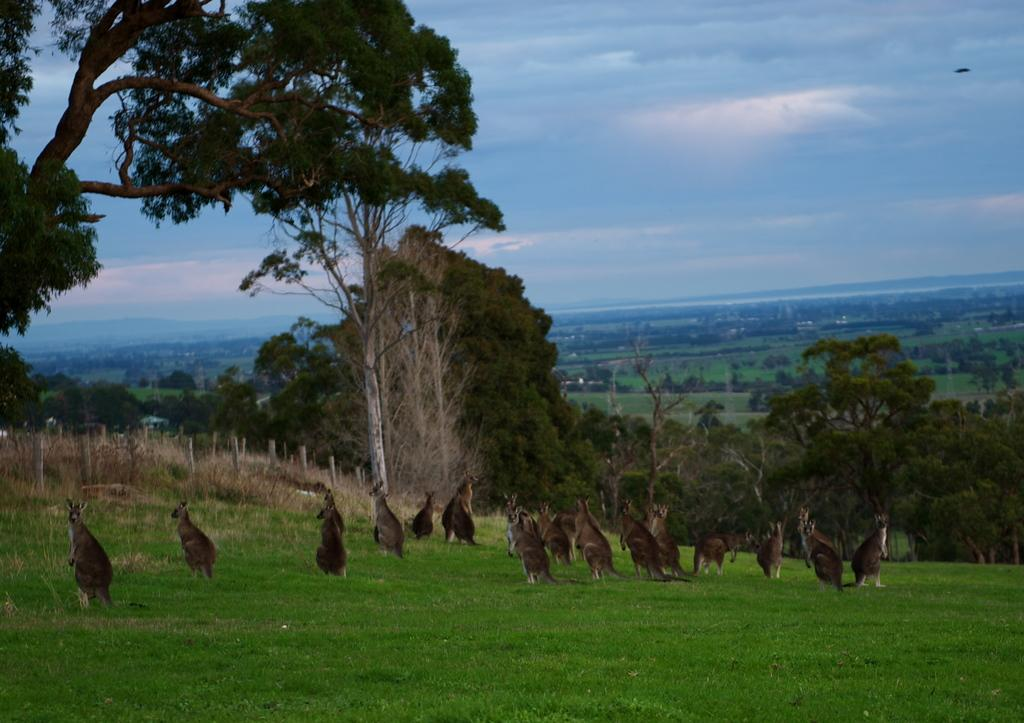What type of animals are in the image? There are kangaroos in the image. What is at the bottom of the image? There is grass at the bottom of the image. What can be seen in the background of the image? There are trees in the background of the image. What is visible at the top of the image? The sky is visible at the top of the image. What type of produce is being sold by the organization in the image? There is no produce or organization present in the image; it features kangaroos in a grassy area with trees in the background and the sky visible at the top. 